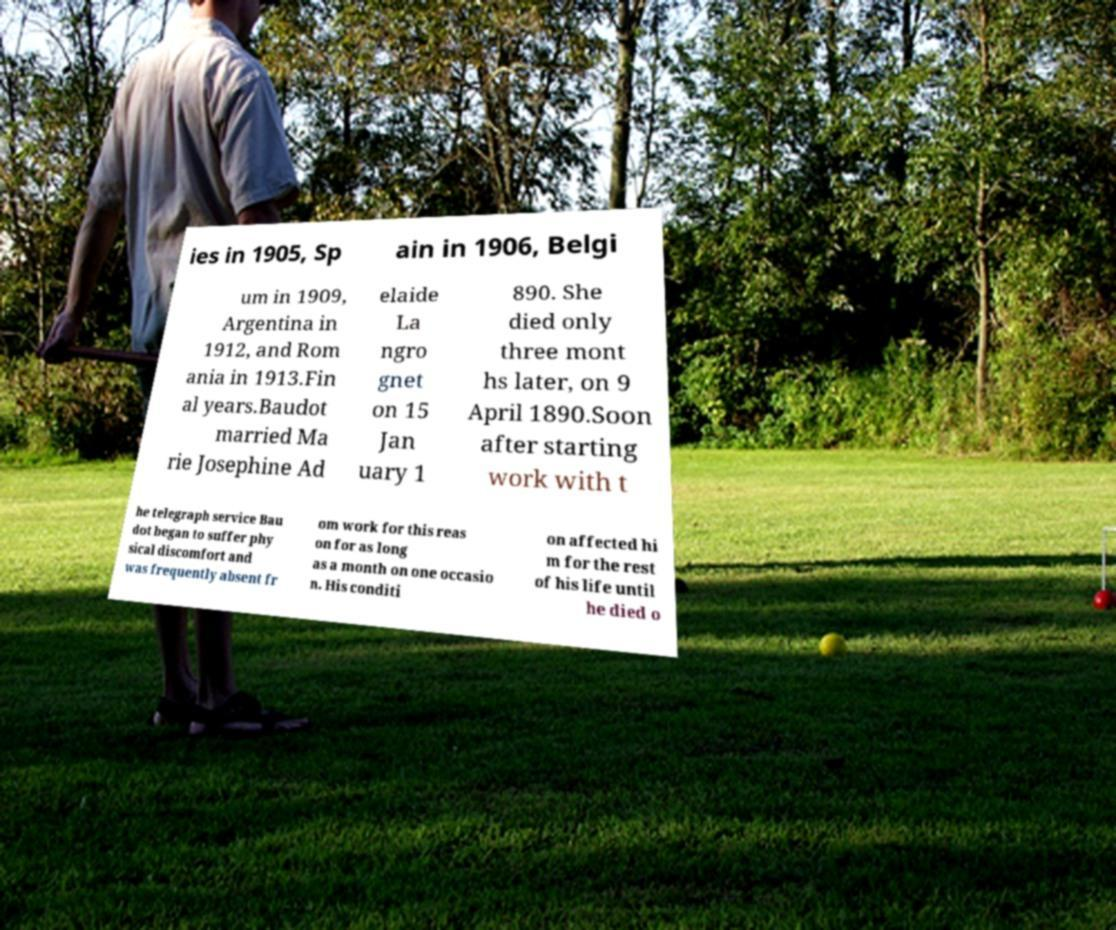There's text embedded in this image that I need extracted. Can you transcribe it verbatim? ies in 1905, Sp ain in 1906, Belgi um in 1909, Argentina in 1912, and Rom ania in 1913.Fin al years.Baudot married Ma rie Josephine Ad elaide La ngro gnet on 15 Jan uary 1 890. She died only three mont hs later, on 9 April 1890.Soon after starting work with t he telegraph service Bau dot began to suffer phy sical discomfort and was frequently absent fr om work for this reas on for as long as a month on one occasio n. His conditi on affected hi m for the rest of his life until he died o 